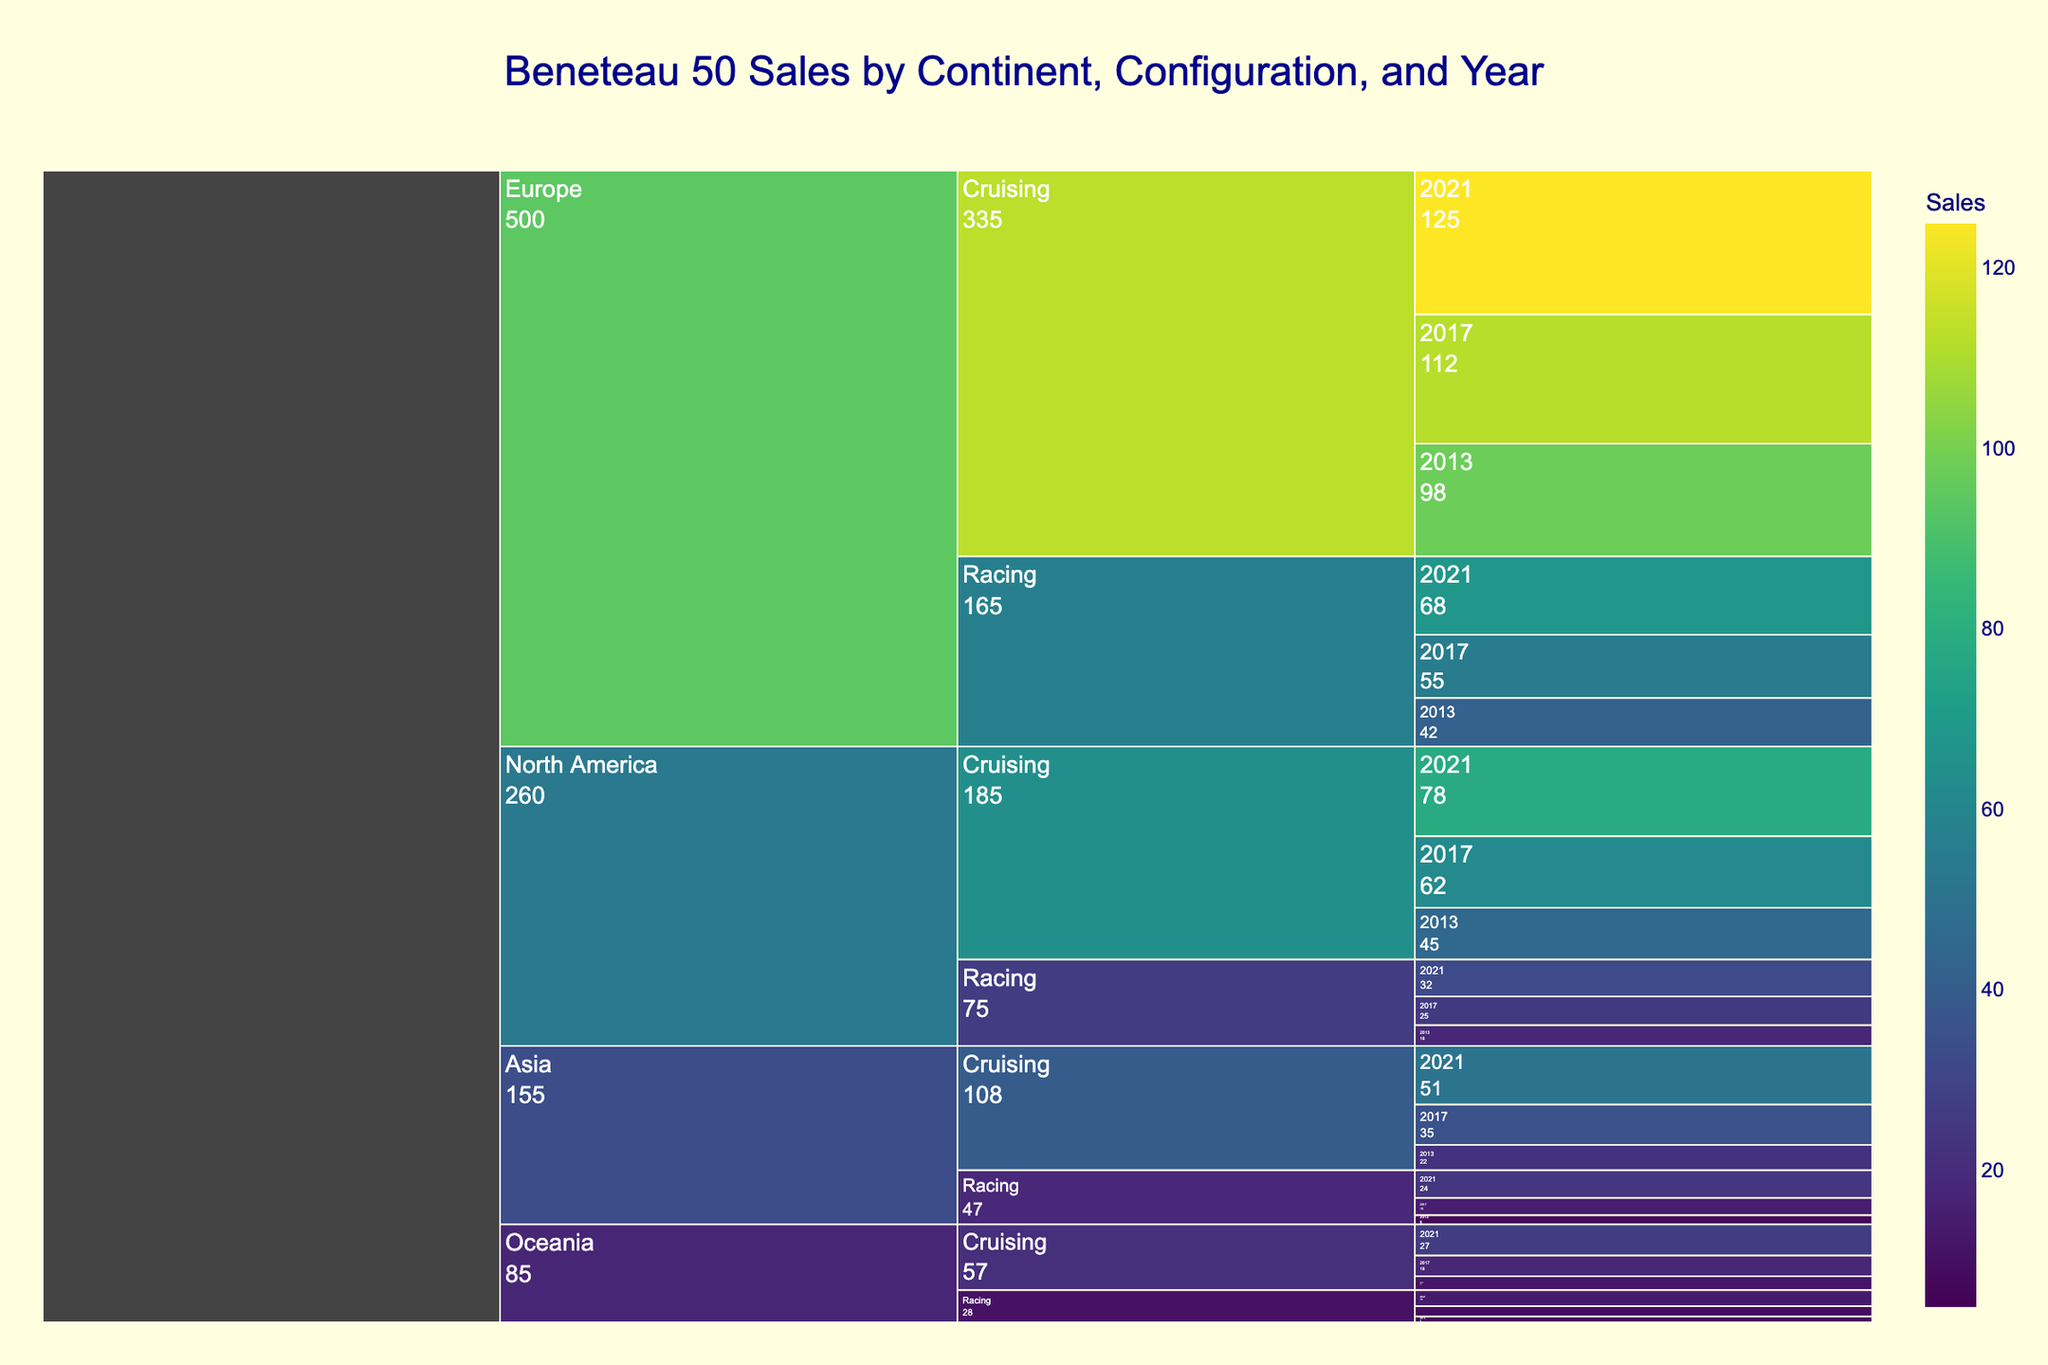What is the title of the Icicle Chart? The title of the chart is usually displayed at the top and indicates what the chart represents. In this case, the title is "Beneteau 50 Sales by Continent, Configuration, and Year".
Answer: Beneteau 50 Sales by Continent, Configuration, and Year Which continent had the highest number of Beneteau 50 sales in 2021? Look at the segment for 2021 and identify the continent with the largest value. The larger the segment, the higher the number of sales.
Answer: Europe How many Beneteau 50 were sold in North America across all configurations in 2017? Sum the sales figures for North America in 2017 for both Cruising and Racing configurations. The sales are 62 (Cruising) + 25 (Racing).
Answer: 87 What is the difference in sales between Cruising and Racing configurations in Asia in 2021? Subtract the sales of the Racing configuration from the Cruising configuration in Asia for 2021. The sales are 51 (Cruising) - 24 (Racing).
Answer: 27 Which configuration showed the greatest increase in sales in Europe from 2013 to 2021? Compare the sales of Cruising and Racing configurations in Europe between 2013 and 2021. The increase for Cruising is 125 - 98 and for Racing is 68 - 42. Identify the configuration with the greater increase.
Answer: Cruising What are the total sales of Beneteau 50 in Oceania over the past decade? Sum the sales for all years and both configurations in Oceania. The total is 12 (Cruising 2013) + 18 (Cruising 2017) + 27 (Cruising 2021) + 5 (Racing 2013) + 9 (Racing 2017) + 14 (Racing 2021).
Answer: 85 Does the Racing configuration in North America show a consistent increase in sales over the years? Check the sales figures for the Racing configuration in North America for 2013, 2017, and 2021 to see if they increase steadily. They are 18 (2013), 25 (2017), and 32 (2021).
Answer: Yes How do the sales of the Beneteau 50 in Asia compare to those in Oceania for the year 2013? Compare the total sales in Asia and Oceania for 2013. In Asia, the sales are 22 (Cruising) + 8 (Racing) and in Oceania, they are 12 (Cruising) + 5 (Racing).
Answer: Asia has higher sales Which year had the highest total sales for the Beneteau 50 in Europe? Sum the sales for all configurations and identify the year with the highest total. For Europe, the totals are 140 (2013), 167 (2017), and 193 (2021).
Answer: 2021 